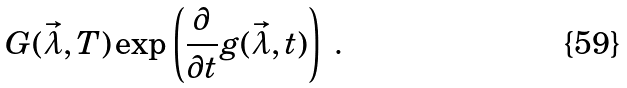<formula> <loc_0><loc_0><loc_500><loc_500>G ( \vec { \lambda } , T ) \exp \left ( \frac { \partial } { \partial t } g ( \vec { \lambda } , t ) \right ) \ .</formula> 